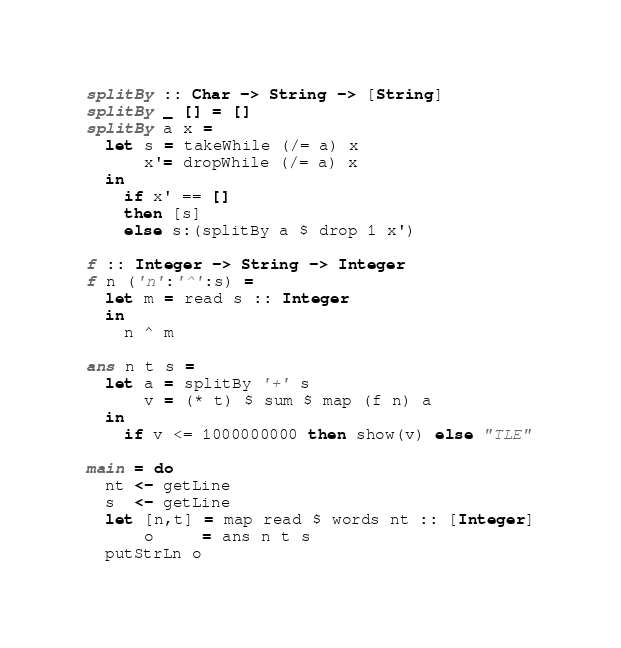<code> <loc_0><loc_0><loc_500><loc_500><_Haskell_>splitBy :: Char -> String -> [String]
splitBy _ [] = []
splitBy a x =
  let s = takeWhile (/= a) x
      x'= dropWhile (/= a) x
  in
    if x' == []
    then [s]
    else s:(splitBy a $ drop 1 x')

f :: Integer -> String -> Integer
f n ('n':'^':s) =
  let m = read s :: Integer
  in
    n ^ m

ans n t s =
  let a = splitBy '+' s
      v = (* t) $ sum $ map (f n) a
  in
    if v <= 1000000000 then show(v) else "TLE"

main = do
  nt <- getLine
  s  <- getLine
  let [n,t] = map read $ words nt :: [Integer]
      o     = ans n t s
  putStrLn o

</code> 